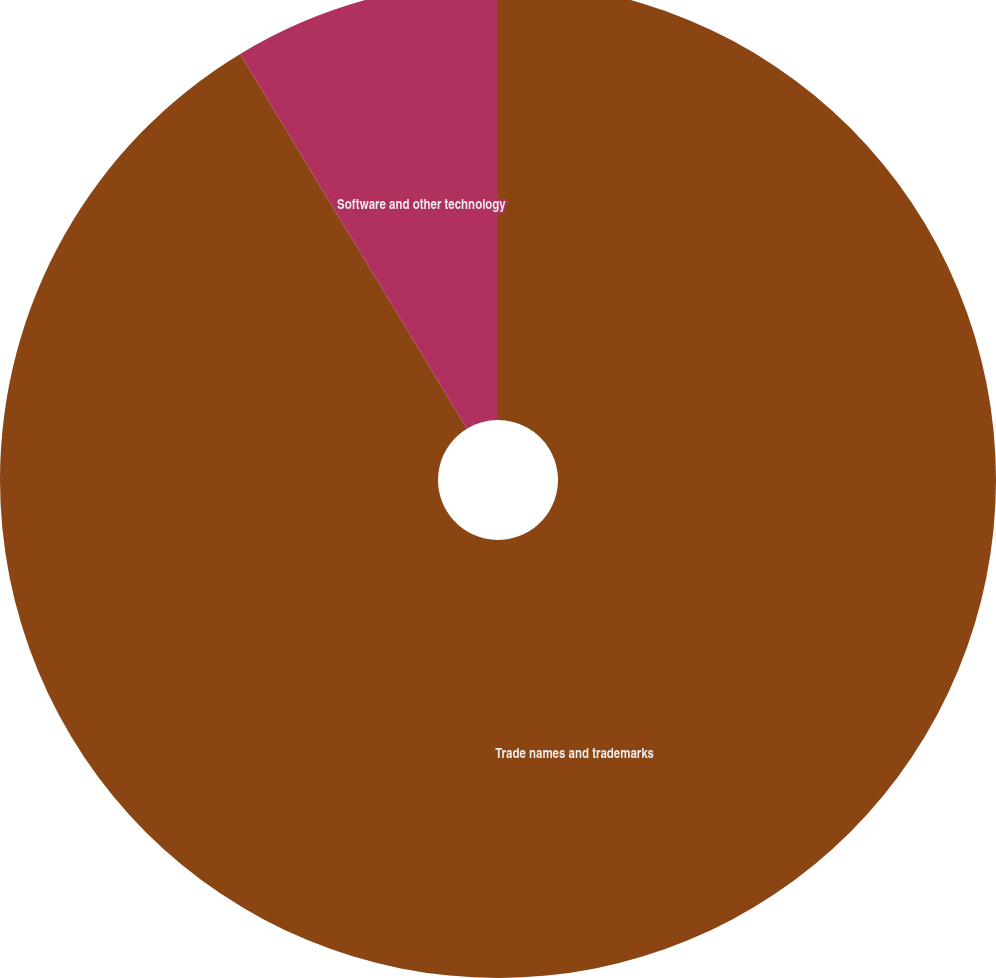Convert chart to OTSL. <chart><loc_0><loc_0><loc_500><loc_500><pie_chart><fcel>Trade names and trademarks<fcel>Software and other technology<nl><fcel>91.34%<fcel>8.66%<nl></chart> 